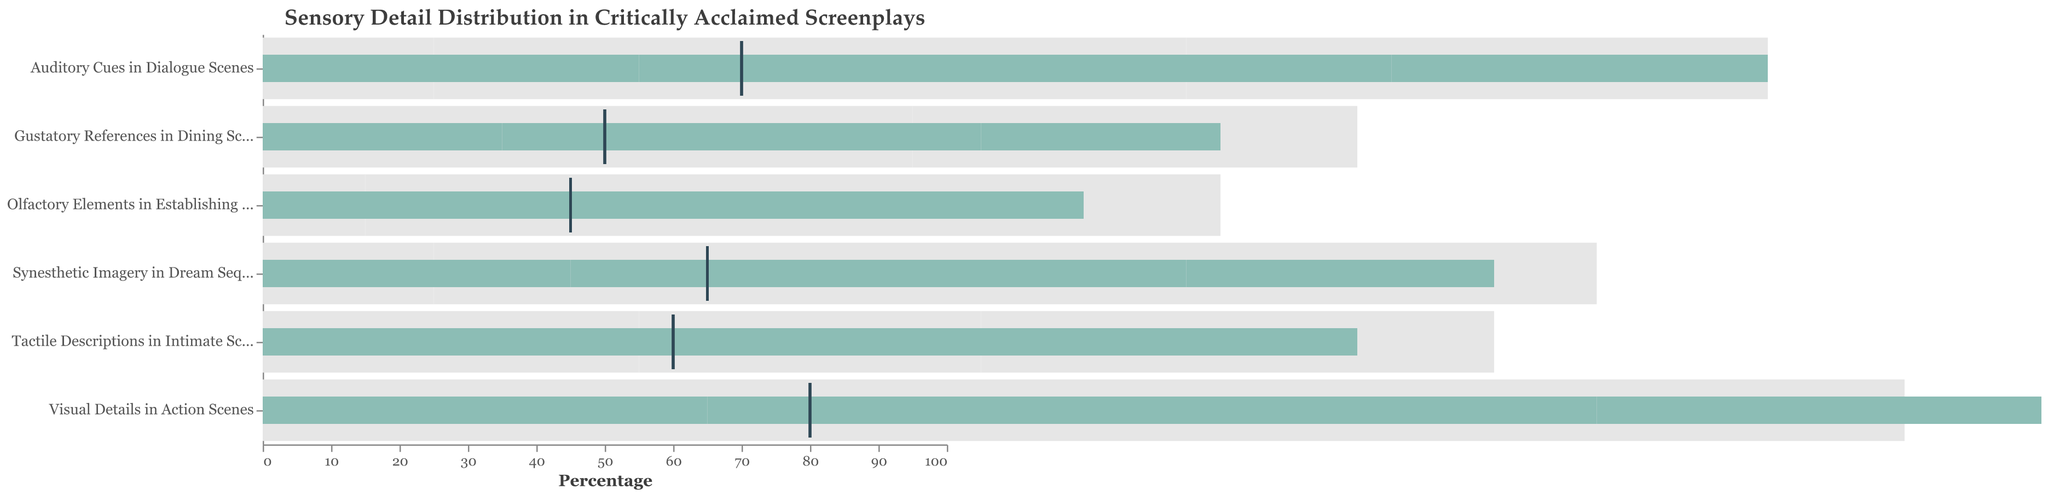Which scene type has the highest actual sensory detail percentage? The actual sensory detail percentages are provided for each scene type. Visual Details in Action Scenes has the highest at 65.
Answer: Visual Details in Action Scenes What is the comparative percentage for Gustatory References in Dining Scenes? The comparative percentages are shown as ticks on the plot. For Gustatory References in Dining Scenes, the tick is at 50.
Answer: 50 How much higher is the comparative percentage than the actual percentage for Tactile Descriptions in Intimate Scenes? The actual percentage for Tactile Descriptions in Intimate Scenes is 40, and the comparative percentage is 60. The difference is 60 - 40.
Answer: 20 Which sensory detail has the closest actual and comparative percentages? By looking at the actual and comparative values, Tactile Descriptions in Intimate Scenes has the closest values: 40 (actual) and 60 (comparative) with a difference of 20.
Answer: Tactile Descriptions in Intimate Scenes Which scene type has the lowest actual sensory detail percentage? The lowest actual sensory detail percentage is for Olfactory Elements in Establishing Shots at 30.
Answer: Olfactory Elements in Establishing Shots Whose actual sensory detail falls into the '70-90' range? Only Visual Details in Action Scenes with an actual percentage of 65 falls within its third range segment '70-90'.
Answer: Visual Details in Action Scenes What is the average actual percentage for all scene types? Sum the actual percentages: 65 + 55 + 40 + 30 + 35 + 45 = 270. There are 6 scene types, so average is 270 / 6.
Answer: 45 Which scene type has the most comprehensive range of sensory details? Synesthetic Imagery in Dream Sequences has ranges spanning from 25 to 75, giving it the widest range across four segments.
Answer: Synesthetic Imagery in Dream Sequences What is the mid-point of the second range for Auditory Cues in Dialogue Scenes? The second range for Auditory Cues in Dialogue Scenes is from 45 to 65. The mid-point can be calculated as (45 + 65) / 2.
Answer: 55 How does the actual percentage of Olfactory Elements in Establishing Shots compare to the lowest range threshold of Gustatory References in Dining Scenes? The actual percentage of Olfactory Elements in Establishing Shots is 30. The lowest range threshold for Gustatory References in Dining Scenes is 20. Since 30 > 20, Olfactory is higher than the lowest threshold for Gustatory.
Answer: Higher 